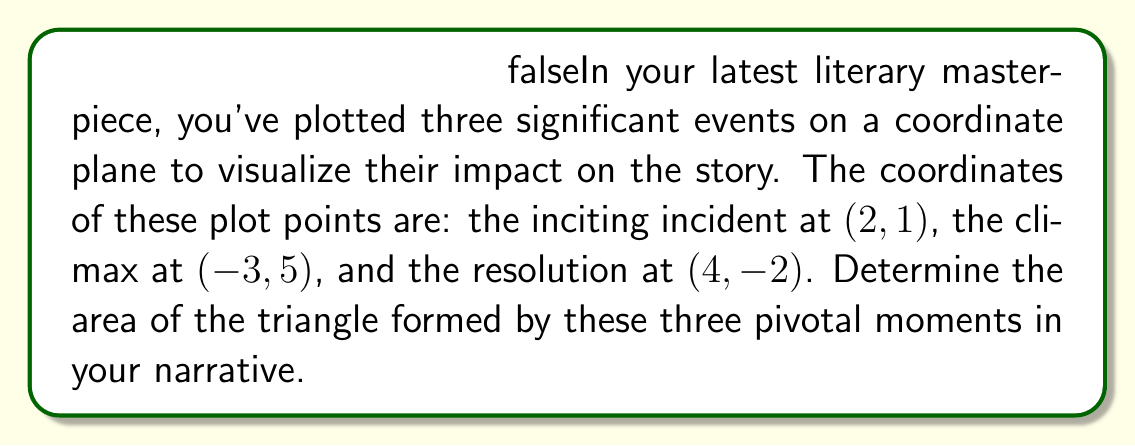Provide a solution to this math problem. To find the area of a triangle given three points on a coordinate plane, we can use the formula:

$$\text{Area} = \frac{1}{2}|x_1(y_2 - y_3) + x_2(y_3 - y_1) + x_3(y_1 - y_2)|$$

Where $(x_1, y_1)$, $(x_2, y_2)$, and $(x_3, y_3)$ are the coordinates of the three points.

Let's assign our points:
$(x_1, y_1) = (2, 1)$ (inciting incident)
$(x_2, y_2) = (-3, 5)$ (climax)
$(x_3, y_3) = (4, -2)$ (resolution)

Now, let's substitute these values into our formula:

$$\begin{align*}
\text{Area} &= \frac{1}{2}|2(5 - (-2)) + (-3)((-2) - 1) + 4(1 - 5)|\\
&= \frac{1}{2}|2(7) + (-3)(-3) + 4(-4)|\\
&= \frac{1}{2}|14 + 9 - 16|\\
&= \frac{1}{2}|7|\\
&= \frac{1}{2}(7)\\
&= 3.5
\end{align*}$$

Therefore, the area of the triangle formed by your three plot points is 3.5 square units.

[asy]
unitsize(20);
draw((-4,-3)--(5,6),gray);
draw((-4,-3)--(5,-3),gray);
draw((-4,6)--(5,6),gray);
draw((-4,-3)--(-4,6),gray);
draw((5,-3)--(5,6),gray);
for(int i=-4; i<=5; ++i) {
  draw((i,-3)--(i,6),gray+0.5bp);
  draw((-4,i)--(5,i),gray+0.5bp);
}

dot((2,1));
dot((-3,5));
dot((4,-2));
draw((2,1)--(-3,5)--(4,-2)--cycle,blue);
label("(2,1)",(2,1),SE);
label("(-3,5)",(-3,5),NW);
label("(4,-2)",(4,-2),SE);
label("Inciting Incident",(2,1),E);
label("Climax",(-3,5),N);
label("Resolution",(4,-2),S);
[/asy]
Answer: The area of the triangle formed by the three plot points is 3.5 square units. 